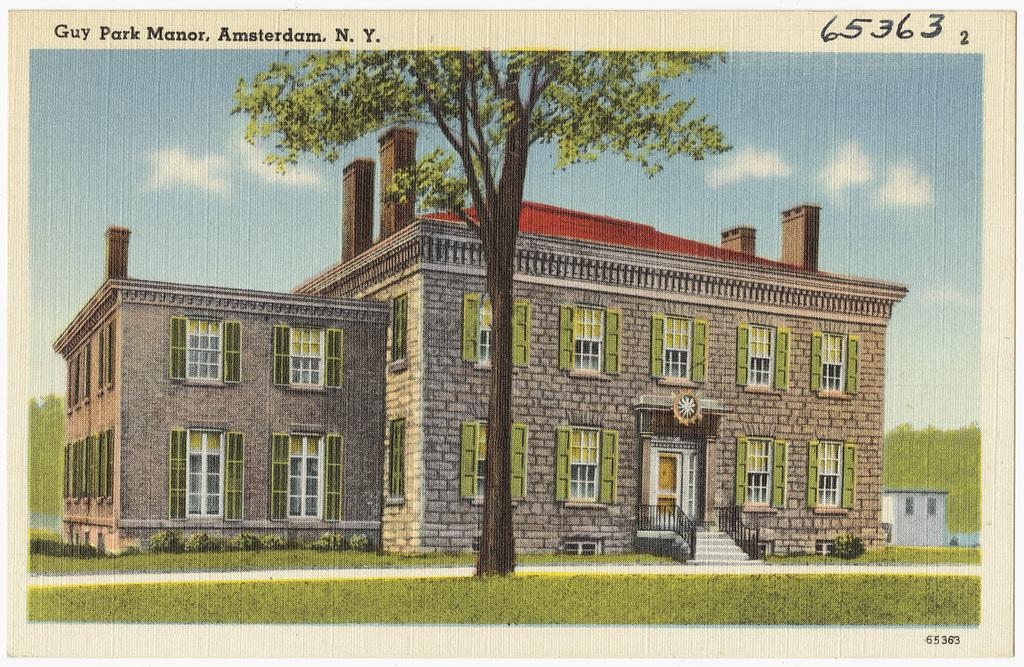What type of structures can be seen in the image? There are buildings in the image. What type of plant is present in the image? There is a tree in the image. What is visible at the bottom of the image? The ground is visible at the bottom of the image. What is visible in the sky at the top of the image? There are clouds in the sky at the top of the image. Can you tell me how many goldfish are swimming in the tree in the image? There are no goldfish present in the image, and goldfish cannot swim in trees. 